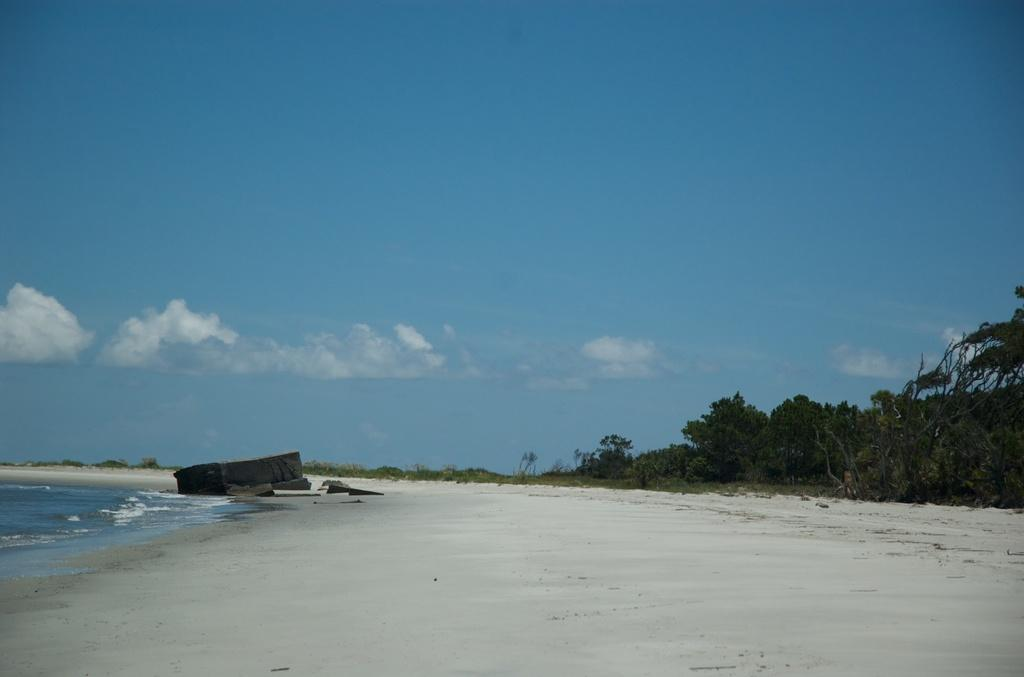What type of natural environment is depicted in the image? There is a beach in the image. What body of water is visible on the left side of the image? There is an ocean on the left side of the image. What type of vegetation is on the right side of the image? There are trees on the right side of the image. What can be seen in the sky in the background of the image? There are clouds in the sky in the background of the image. Can you provide an example of a spy hiding behind the trees in the image? There is no spy present in the image; it depicts a beach with an ocean, trees, and clouds in the sky. 